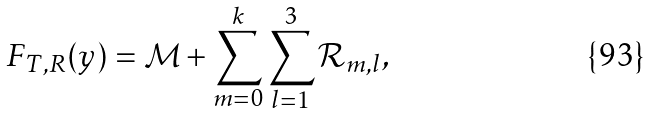Convert formula to latex. <formula><loc_0><loc_0><loc_500><loc_500>F _ { T , R } ( y ) = \mathcal { M } + \sum _ { m = 0 } ^ { k } \sum _ { l = 1 } ^ { 3 } \mathcal { R } _ { m , l } ,</formula> 